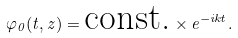<formula> <loc_0><loc_0><loc_500><loc_500>\varphi _ { 0 } ( t , z ) = \text {const.} \times e ^ { - i k t } .</formula> 